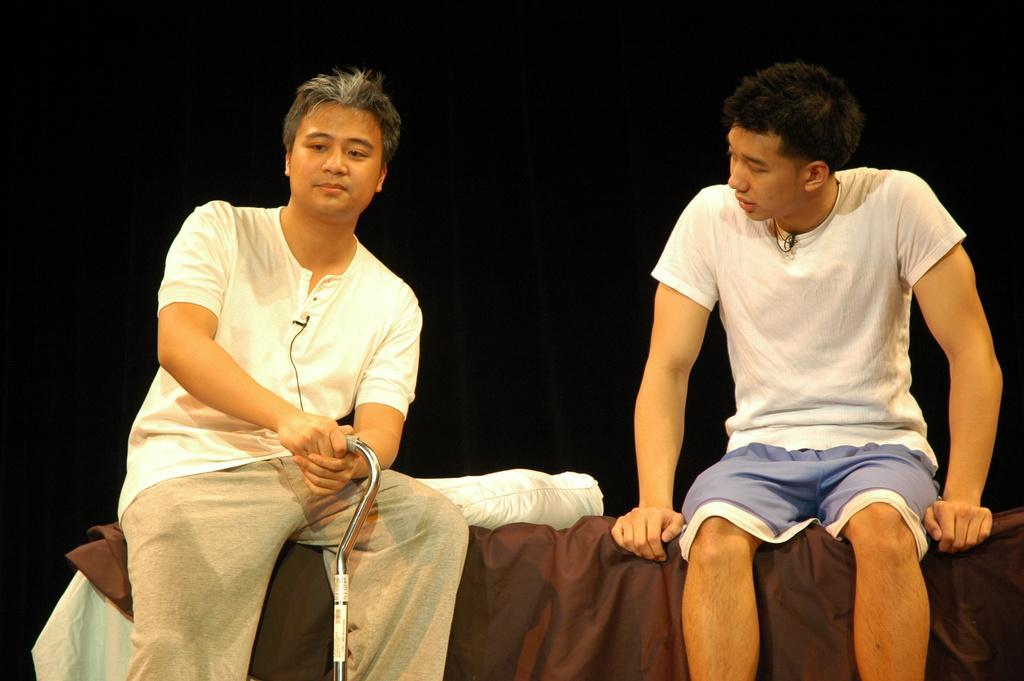Can you describe this image briefly? There are two men sitting on cloth and this man holding an object and we can see pillow. In the background it is dark. 